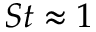Convert formula to latex. <formula><loc_0><loc_0><loc_500><loc_500>S t \approx 1</formula> 